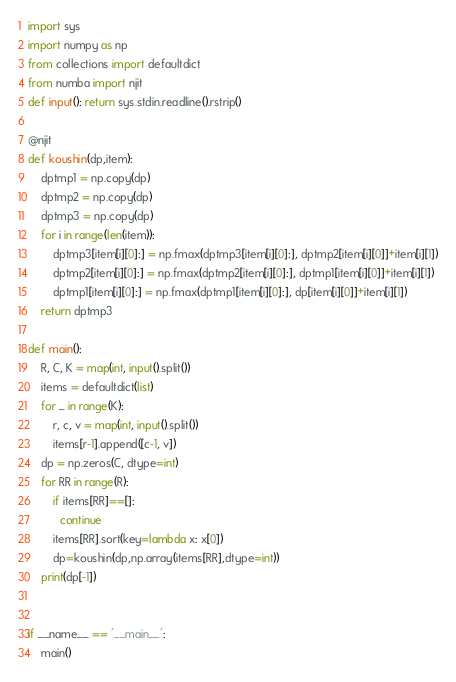Convert code to text. <code><loc_0><loc_0><loc_500><loc_500><_Python_>import sys
import numpy as np
from collections import defaultdict
from numba import njit
def input(): return sys.stdin.readline().rstrip()

@njit
def koushin(dp,item):
    dptmp1 = np.copy(dp)
    dptmp2 = np.copy(dp)
    dptmp3 = np.copy(dp)
    for i in range(len(item)):
        dptmp3[item[i][0]:] = np.fmax(dptmp3[item[i][0]:], dptmp2[item[i][0]]+item[i][1])
        dptmp2[item[i][0]:] = np.fmax(dptmp2[item[i][0]:], dptmp1[item[i][0]]+item[i][1])
        dptmp1[item[i][0]:] = np.fmax(dptmp1[item[i][0]:], dp[item[i][0]]+item[i][1])
    return dptmp3

def main():
    R, C, K = map(int, input().split())
    items = defaultdict(list)
    for _ in range(K):
        r, c, v = map(int, input().split())
        items[r-1].append([c-1, v])
    dp = np.zeros(C, dtype=int)
    for RR in range(R):
        if items[RR]==[]:
          continue
        items[RR].sort(key=lambda x: x[0])
        dp=koushin(dp,np.array(items[RR],dtype=int))
    print(dp[-1])


if __name__ == '__main__':
    main()</code> 